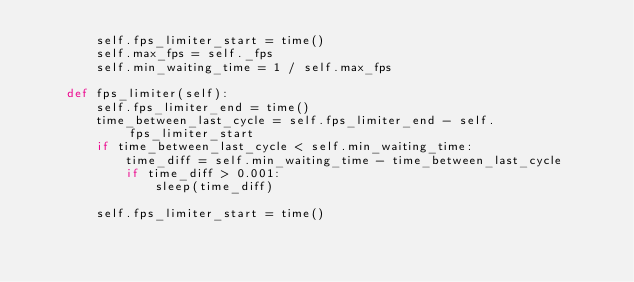<code> <loc_0><loc_0><loc_500><loc_500><_Python_>        self.fps_limiter_start = time()
        self.max_fps = self._fps
        self.min_waiting_time = 1 / self.max_fps

    def fps_limiter(self):
        self.fps_limiter_end = time()
        time_between_last_cycle = self.fps_limiter_end - self.fps_limiter_start
        if time_between_last_cycle < self.min_waiting_time:
            time_diff = self.min_waiting_time - time_between_last_cycle
            if time_diff > 0.001:
                sleep(time_diff)

        self.fps_limiter_start = time()
</code> 